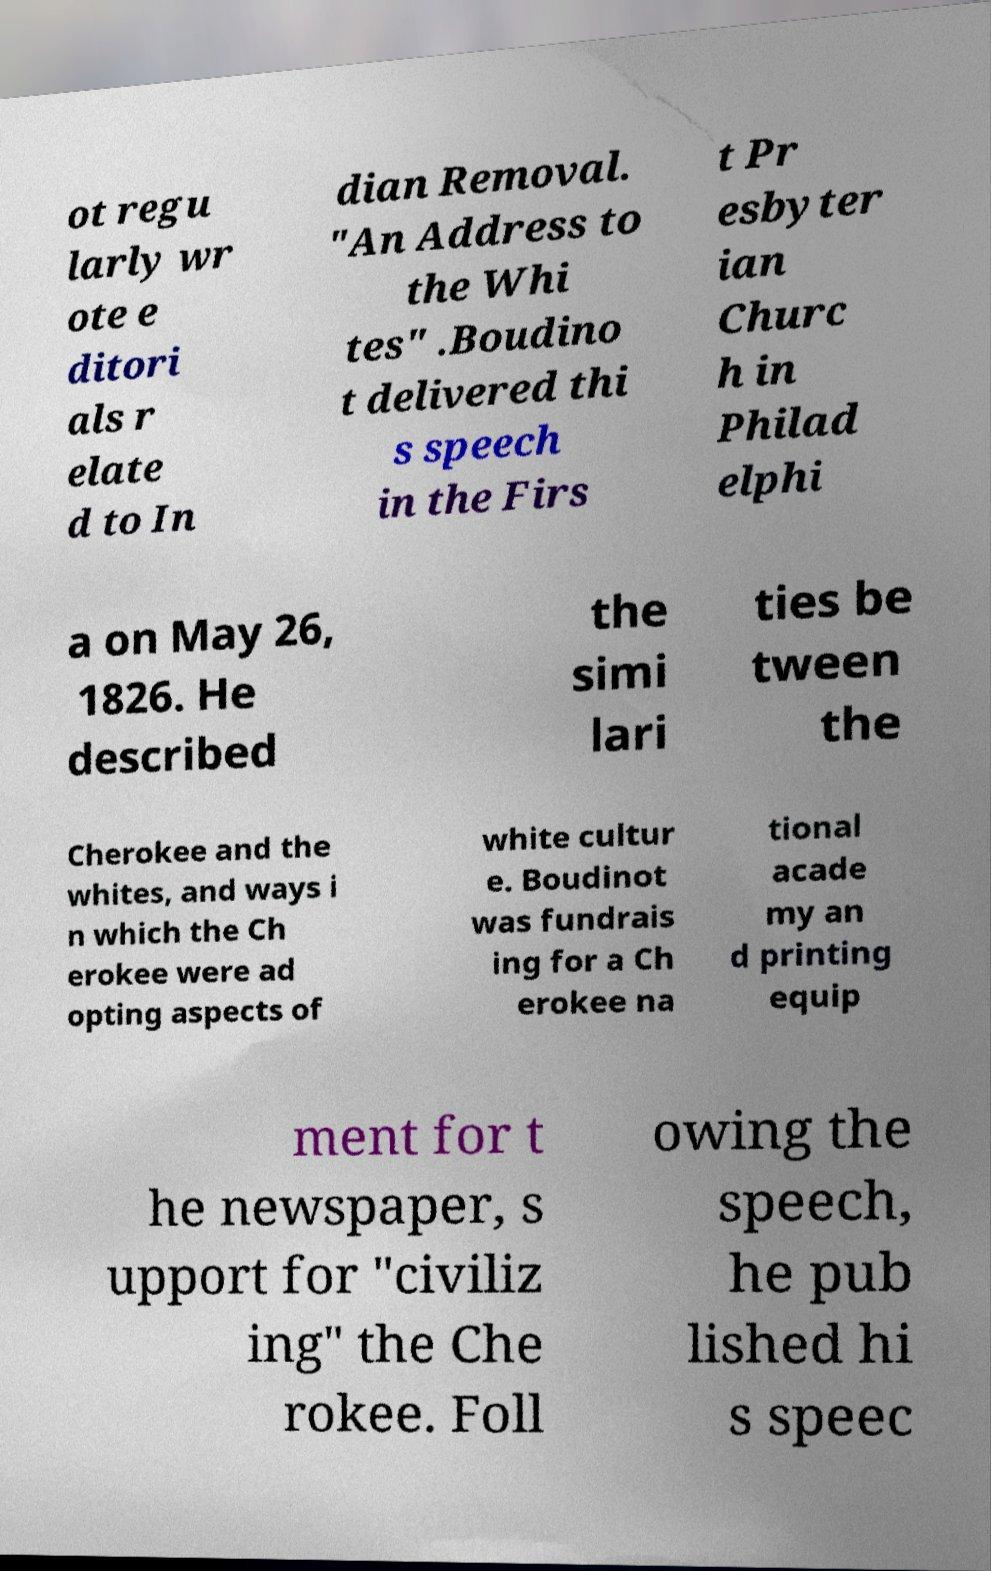For documentation purposes, I need the text within this image transcribed. Could you provide that? ot regu larly wr ote e ditori als r elate d to In dian Removal. "An Address to the Whi tes" .Boudino t delivered thi s speech in the Firs t Pr esbyter ian Churc h in Philad elphi a on May 26, 1826. He described the simi lari ties be tween the Cherokee and the whites, and ways i n which the Ch erokee were ad opting aspects of white cultur e. Boudinot was fundrais ing for a Ch erokee na tional acade my an d printing equip ment for t he newspaper, s upport for "civiliz ing" the Che rokee. Foll owing the speech, he pub lished hi s speec 